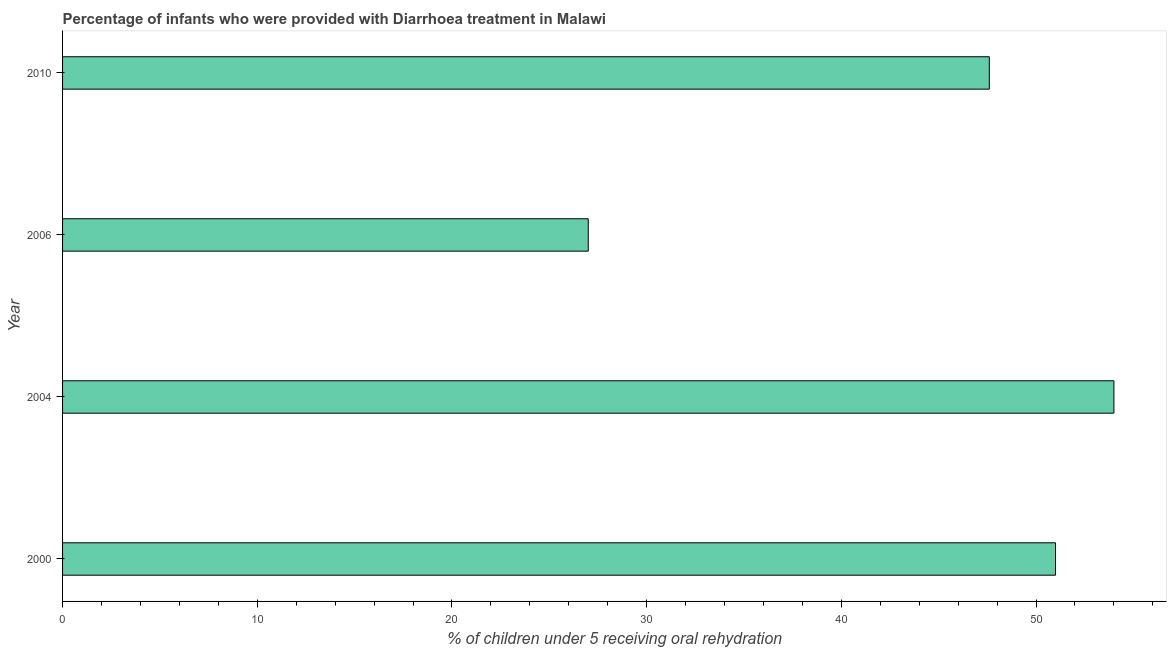Does the graph contain any zero values?
Your answer should be very brief. No. Does the graph contain grids?
Ensure brevity in your answer.  No. What is the title of the graph?
Keep it short and to the point. Percentage of infants who were provided with Diarrhoea treatment in Malawi. What is the label or title of the X-axis?
Your answer should be very brief. % of children under 5 receiving oral rehydration. What is the percentage of children who were provided with treatment diarrhoea in 2010?
Give a very brief answer. 47.6. In which year was the percentage of children who were provided with treatment diarrhoea maximum?
Offer a very short reply. 2004. What is the sum of the percentage of children who were provided with treatment diarrhoea?
Offer a very short reply. 179.6. What is the difference between the percentage of children who were provided with treatment diarrhoea in 2000 and 2006?
Offer a very short reply. 24. What is the average percentage of children who were provided with treatment diarrhoea per year?
Offer a very short reply. 44.9. What is the median percentage of children who were provided with treatment diarrhoea?
Provide a short and direct response. 49.3. Do a majority of the years between 2010 and 2004 (inclusive) have percentage of children who were provided with treatment diarrhoea greater than 48 %?
Offer a terse response. Yes. What is the ratio of the percentage of children who were provided with treatment diarrhoea in 2000 to that in 2004?
Your answer should be compact. 0.94. What is the difference between the highest and the lowest percentage of children who were provided with treatment diarrhoea?
Provide a short and direct response. 27. In how many years, is the percentage of children who were provided with treatment diarrhoea greater than the average percentage of children who were provided with treatment diarrhoea taken over all years?
Provide a succinct answer. 3. Are all the bars in the graph horizontal?
Offer a very short reply. Yes. How many years are there in the graph?
Provide a succinct answer. 4. What is the difference between two consecutive major ticks on the X-axis?
Your response must be concise. 10. Are the values on the major ticks of X-axis written in scientific E-notation?
Your response must be concise. No. What is the % of children under 5 receiving oral rehydration of 2000?
Offer a very short reply. 51. What is the % of children under 5 receiving oral rehydration of 2010?
Provide a short and direct response. 47.6. What is the difference between the % of children under 5 receiving oral rehydration in 2006 and 2010?
Your answer should be compact. -20.6. What is the ratio of the % of children under 5 receiving oral rehydration in 2000 to that in 2004?
Keep it short and to the point. 0.94. What is the ratio of the % of children under 5 receiving oral rehydration in 2000 to that in 2006?
Offer a very short reply. 1.89. What is the ratio of the % of children under 5 receiving oral rehydration in 2000 to that in 2010?
Provide a succinct answer. 1.07. What is the ratio of the % of children under 5 receiving oral rehydration in 2004 to that in 2006?
Your answer should be very brief. 2. What is the ratio of the % of children under 5 receiving oral rehydration in 2004 to that in 2010?
Your response must be concise. 1.13. What is the ratio of the % of children under 5 receiving oral rehydration in 2006 to that in 2010?
Your answer should be very brief. 0.57. 